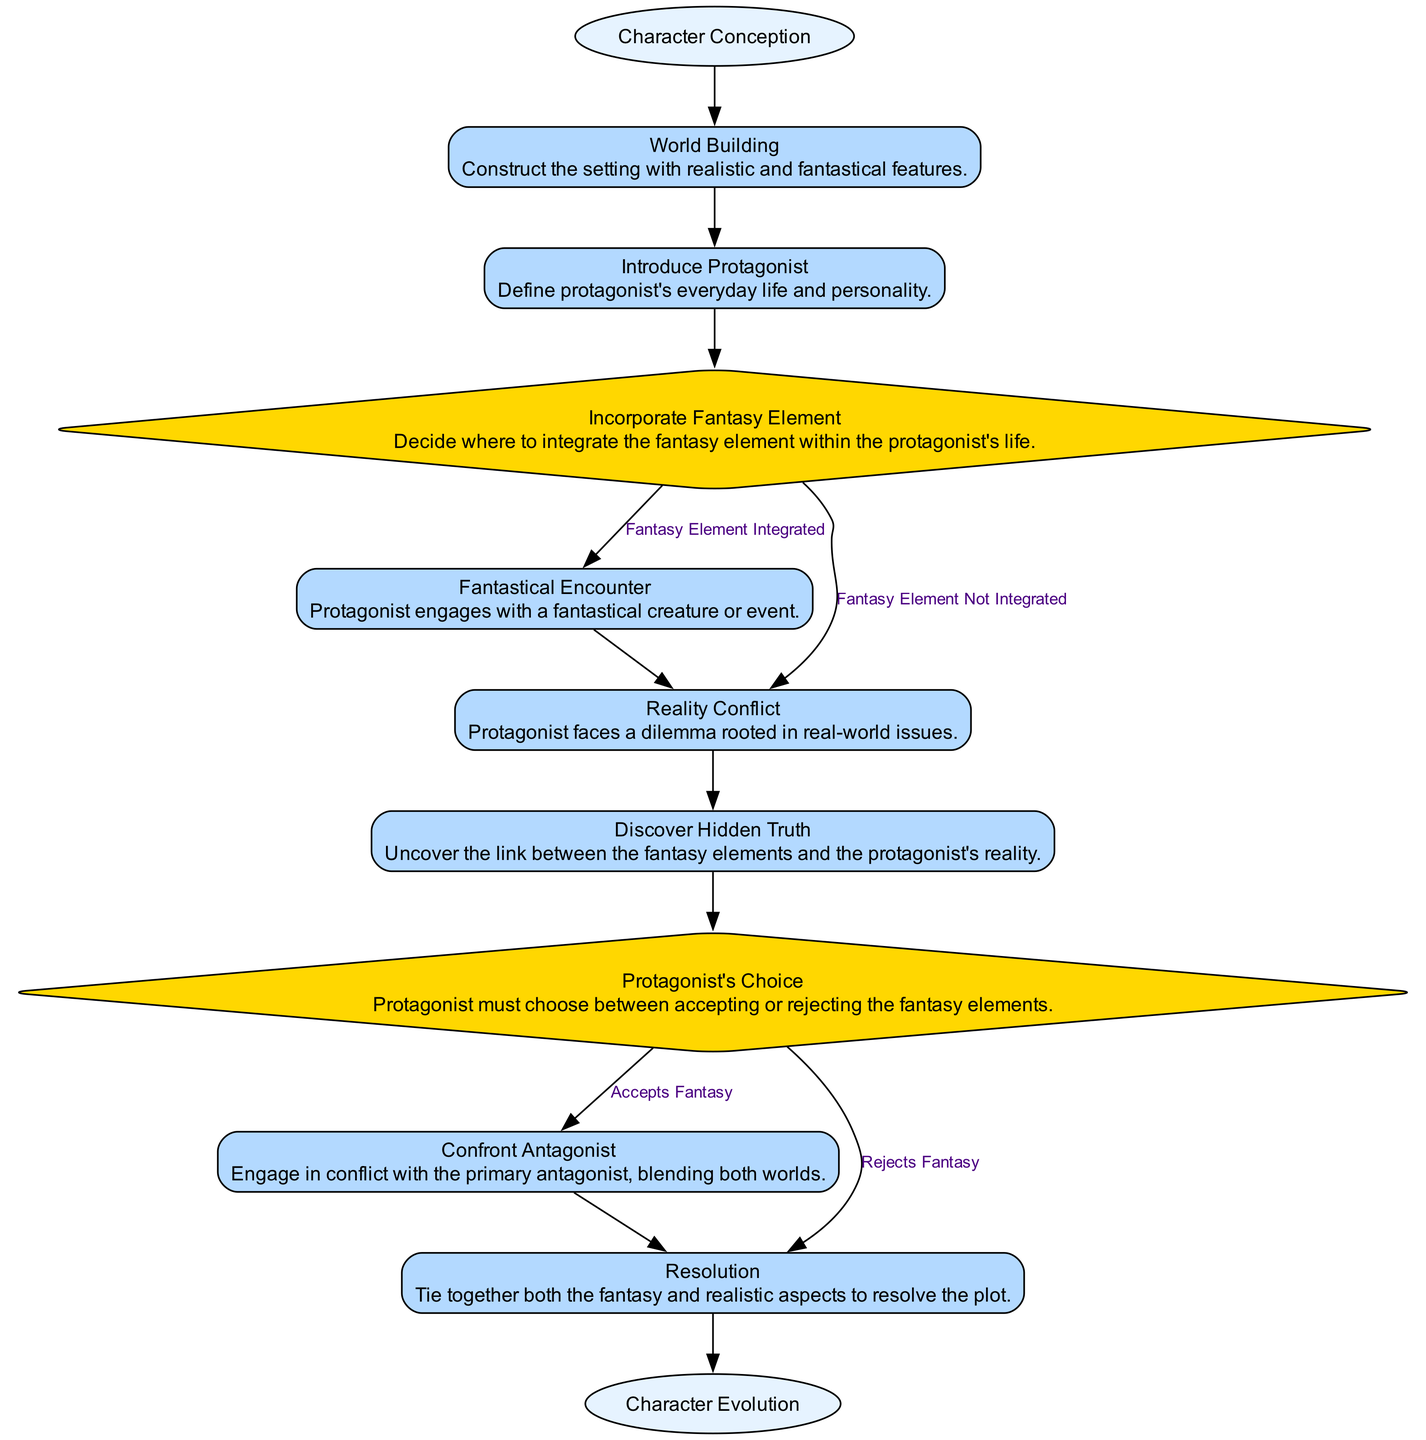What is the starting event in the diagram? The starting event is indicated as the first node in the diagram, labeled "Character Conception."
Answer: Character Conception How many activities are present in the diagram? Counting the nodes of the type "activity," there are six activities listed: "World Building," "Introduce Protagonist," "Fantastical Encounter," "Reality Conflict," "Discover Hidden Truth," and "Confront Antagonist."
Answer: 6 What decision must the protagonist make during their journey? The protagonist must decide whether to accept or reject the fantasy elements, represented by the node "Protagonist's Choice."
Answer: Protagonist's Choice What happens if the fantasy element is integrated into the protagonist's life? If the fantasy element is integrated, the protagonist engages in a "Fantastical Encounter," which connects to the other parts of the story.
Answer: Fantastical Encounter What is the final outcome of the character development journey? The final outcome, depicted in the last node, is termed "Character Evolution," which signifies the growth and changes experienced by the character throughout the journey.
Answer: Character Evolution Which activity directly follows the "Reality Conflict"? After the "Reality Conflict" activity, the next step is "Discover Hidden Truth," where the protagonist uncovers the connection between fantasy elements and their reality.
Answer: Discover Hidden Truth What is a potential outcome if the protagonist rejects the fantasy elements? If the protagonist chooses to reject the fantasy elements, the diagram indicates that they proceed directly to "Resolution," suggesting a different resolution without embracing fantasy.
Answer: Resolution 